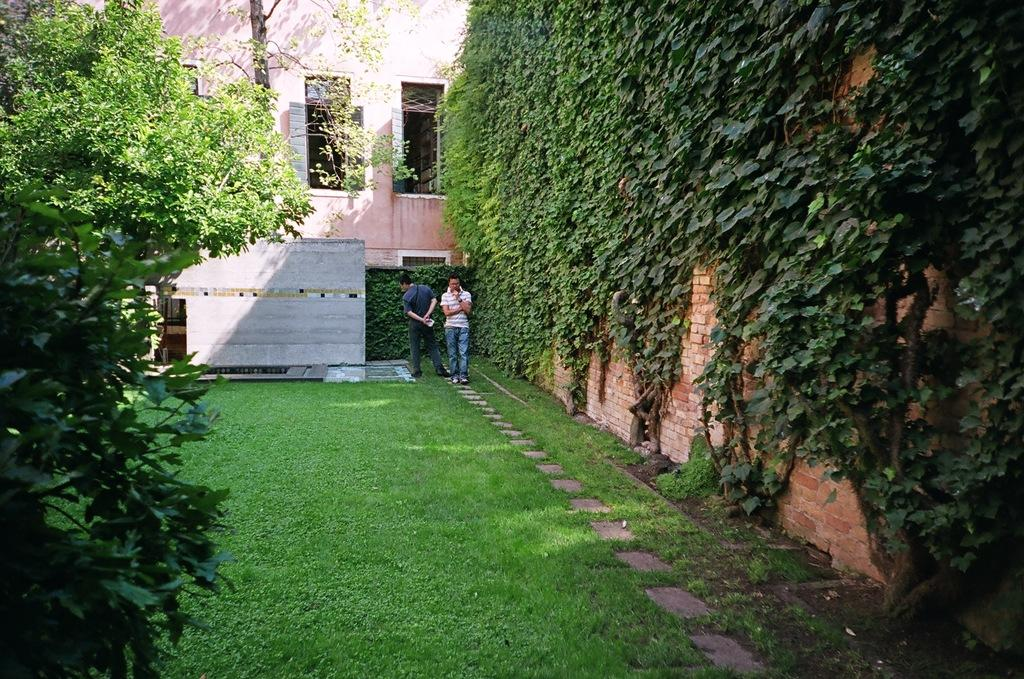How many men are present in the image? There are two men standing in the image. What are the men wearing? The men are wearing clothes. What type of natural environment is visible in the image? There is grass and a tree in the image. What type of structures can be seen in the image? There is a brick wall, a building, and windows in the image. Can you tell me how much the frog owes for the payment of the sponge in the image? There is no frog or sponge in the image, and therefore no payment can be observed. 